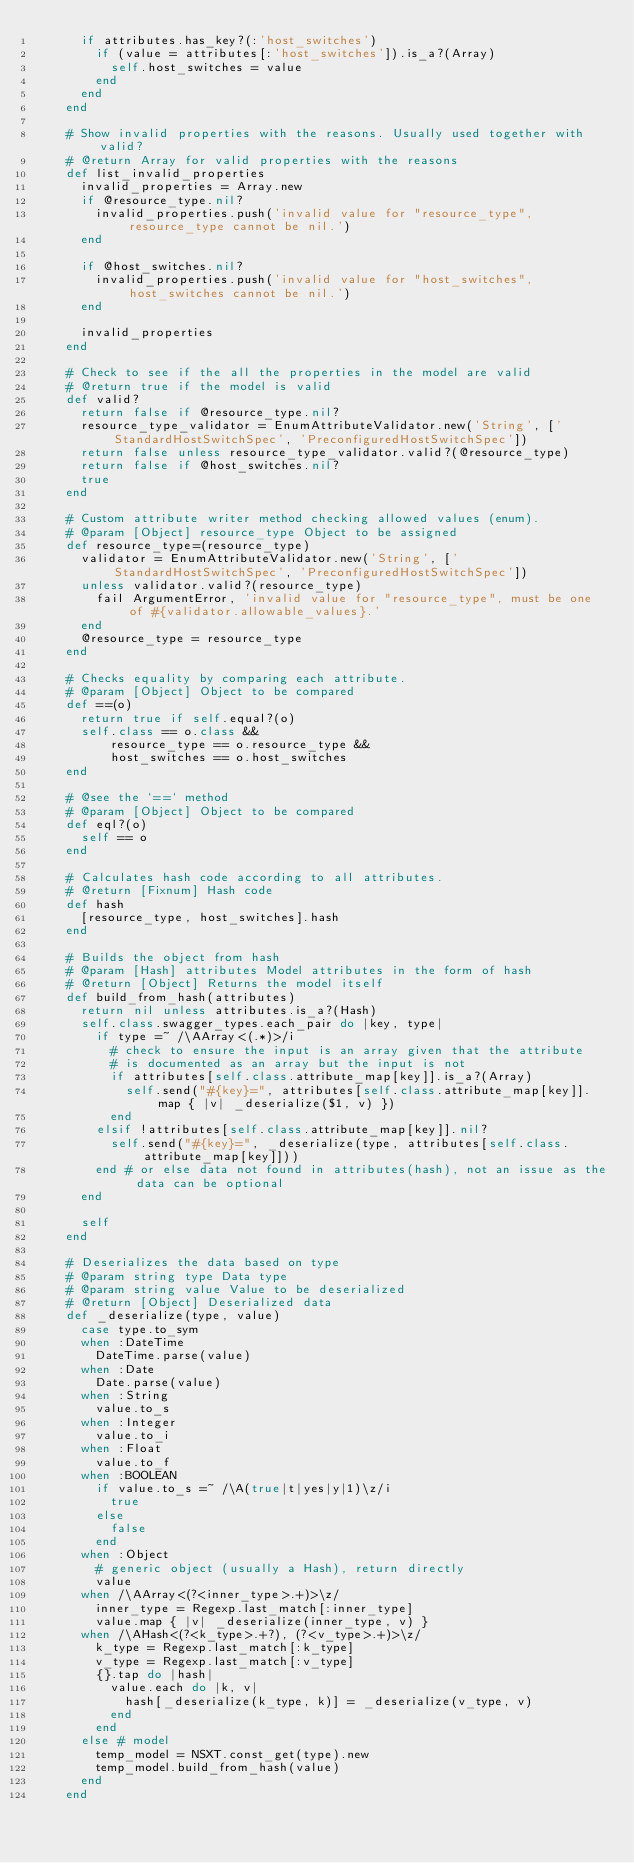<code> <loc_0><loc_0><loc_500><loc_500><_Ruby_>      if attributes.has_key?(:'host_switches')
        if (value = attributes[:'host_switches']).is_a?(Array)
          self.host_switches = value
        end
      end
    end

    # Show invalid properties with the reasons. Usually used together with valid?
    # @return Array for valid properties with the reasons
    def list_invalid_properties
      invalid_properties = Array.new
      if @resource_type.nil?
        invalid_properties.push('invalid value for "resource_type", resource_type cannot be nil.')
      end

      if @host_switches.nil?
        invalid_properties.push('invalid value for "host_switches", host_switches cannot be nil.')
      end

      invalid_properties
    end

    # Check to see if the all the properties in the model are valid
    # @return true if the model is valid
    def valid?
      return false if @resource_type.nil?
      resource_type_validator = EnumAttributeValidator.new('String', ['StandardHostSwitchSpec', 'PreconfiguredHostSwitchSpec'])
      return false unless resource_type_validator.valid?(@resource_type)
      return false if @host_switches.nil?
      true
    end

    # Custom attribute writer method checking allowed values (enum).
    # @param [Object] resource_type Object to be assigned
    def resource_type=(resource_type)
      validator = EnumAttributeValidator.new('String', ['StandardHostSwitchSpec', 'PreconfiguredHostSwitchSpec'])
      unless validator.valid?(resource_type)
        fail ArgumentError, 'invalid value for "resource_type", must be one of #{validator.allowable_values}.'
      end
      @resource_type = resource_type
    end

    # Checks equality by comparing each attribute.
    # @param [Object] Object to be compared
    def ==(o)
      return true if self.equal?(o)
      self.class == o.class &&
          resource_type == o.resource_type &&
          host_switches == o.host_switches
    end

    # @see the `==` method
    # @param [Object] Object to be compared
    def eql?(o)
      self == o
    end

    # Calculates hash code according to all attributes.
    # @return [Fixnum] Hash code
    def hash
      [resource_type, host_switches].hash
    end

    # Builds the object from hash
    # @param [Hash] attributes Model attributes in the form of hash
    # @return [Object] Returns the model itself
    def build_from_hash(attributes)
      return nil unless attributes.is_a?(Hash)
      self.class.swagger_types.each_pair do |key, type|
        if type =~ /\AArray<(.*)>/i
          # check to ensure the input is an array given that the attribute
          # is documented as an array but the input is not
          if attributes[self.class.attribute_map[key]].is_a?(Array)
            self.send("#{key}=", attributes[self.class.attribute_map[key]].map { |v| _deserialize($1, v) })
          end
        elsif !attributes[self.class.attribute_map[key]].nil?
          self.send("#{key}=", _deserialize(type, attributes[self.class.attribute_map[key]]))
        end # or else data not found in attributes(hash), not an issue as the data can be optional
      end

      self
    end

    # Deserializes the data based on type
    # @param string type Data type
    # @param string value Value to be deserialized
    # @return [Object] Deserialized data
    def _deserialize(type, value)
      case type.to_sym
      when :DateTime
        DateTime.parse(value)
      when :Date
        Date.parse(value)
      when :String
        value.to_s
      when :Integer
        value.to_i
      when :Float
        value.to_f
      when :BOOLEAN
        if value.to_s =~ /\A(true|t|yes|y|1)\z/i
          true
        else
          false
        end
      when :Object
        # generic object (usually a Hash), return directly
        value
      when /\AArray<(?<inner_type>.+)>\z/
        inner_type = Regexp.last_match[:inner_type]
        value.map { |v| _deserialize(inner_type, v) }
      when /\AHash<(?<k_type>.+?), (?<v_type>.+)>\z/
        k_type = Regexp.last_match[:k_type]
        v_type = Regexp.last_match[:v_type]
        {}.tap do |hash|
          value.each do |k, v|
            hash[_deserialize(k_type, k)] = _deserialize(v_type, v)
          end
        end
      else # model
        temp_model = NSXT.const_get(type).new
        temp_model.build_from_hash(value)
      end
    end
</code> 